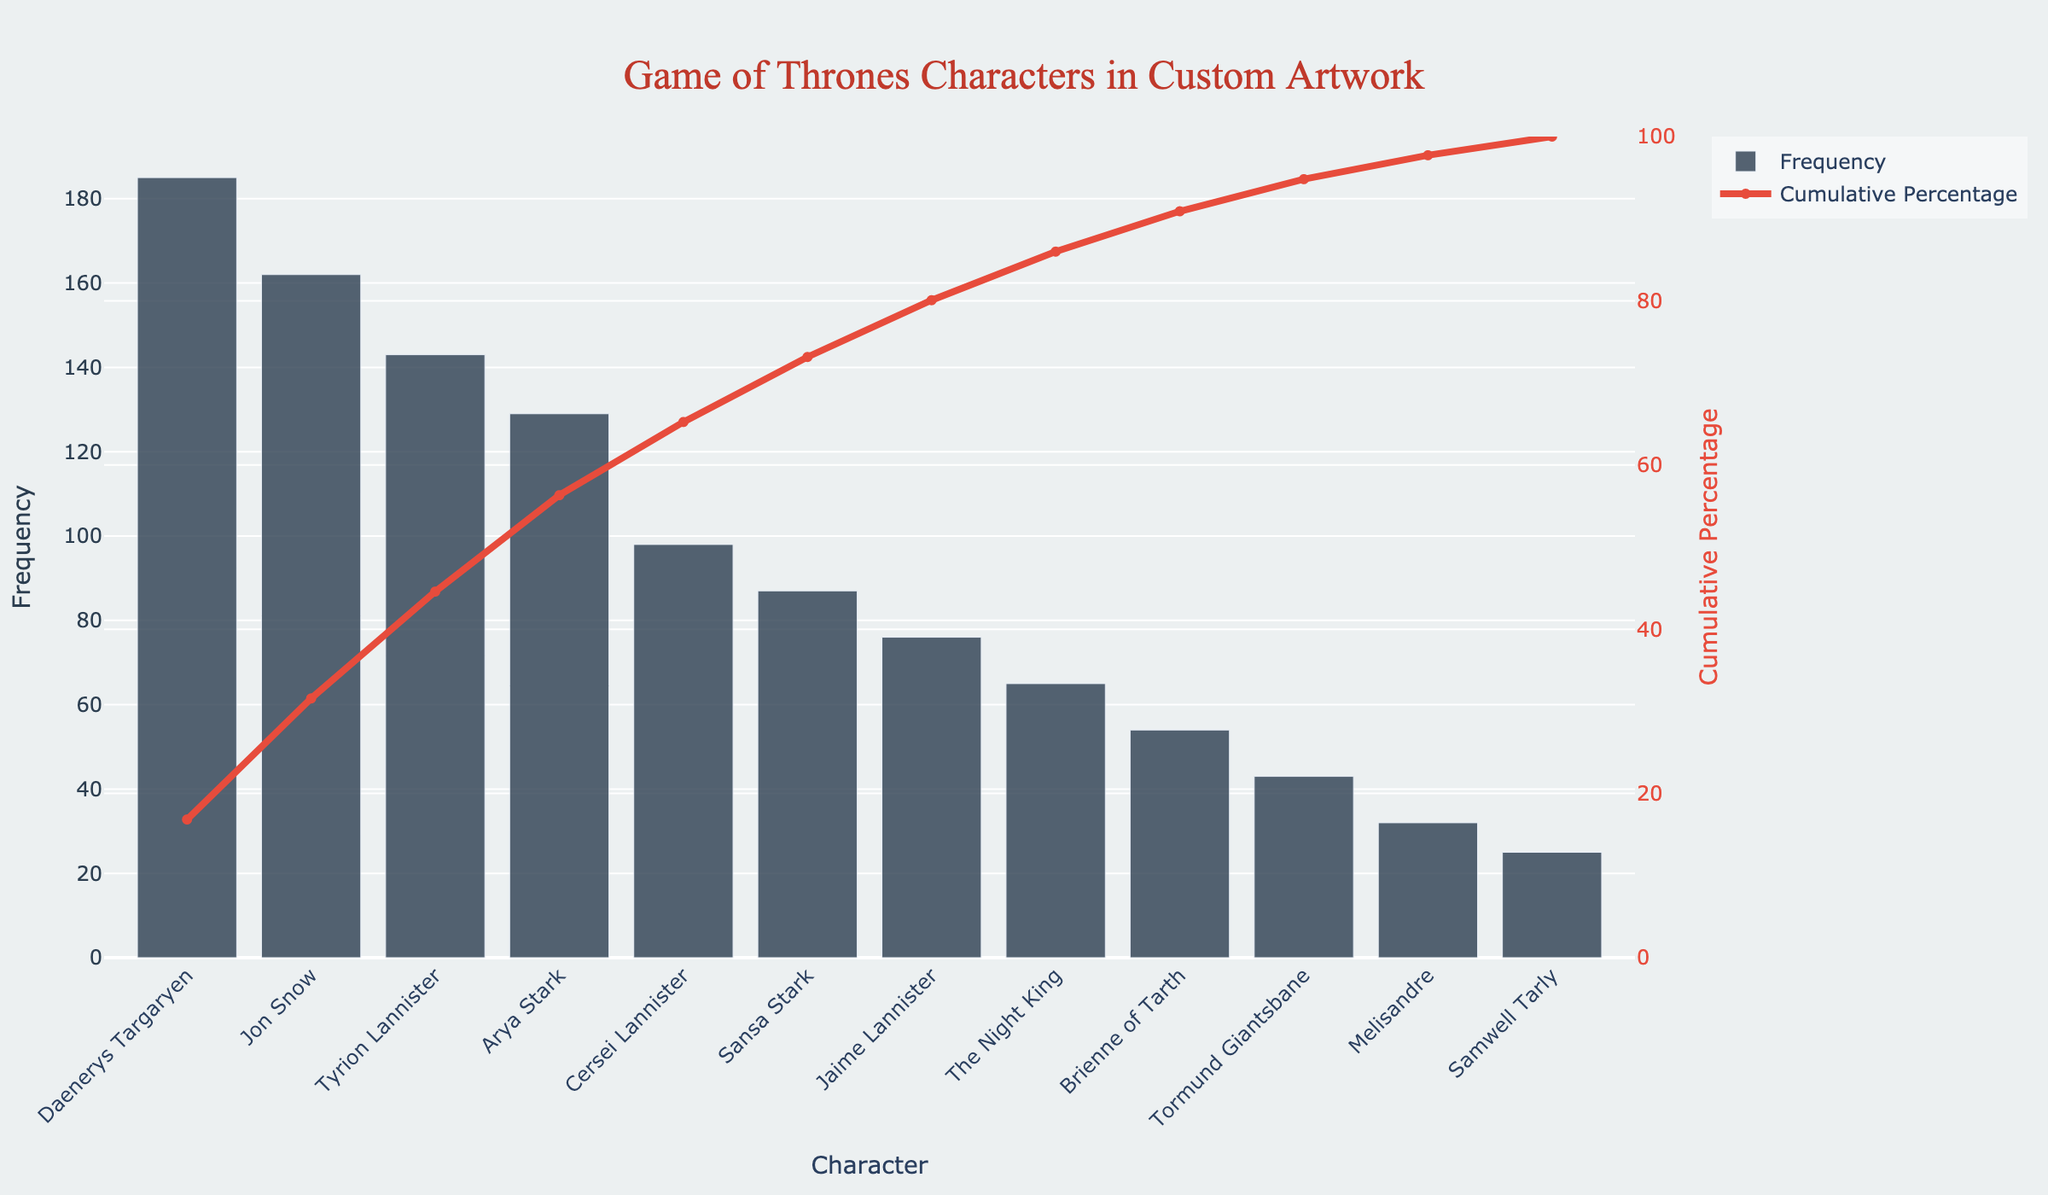What character has the highest frequency in custom artwork? The character with the highest frequency is at the top of the bar chart.
Answer: Daenerys Targaryen What is the cumulative percentage for Daenerys Targaryen and Jon Snow combined? Find the cumulative percentage for Daenerys Targaryen and add it to Jon Snow's frequency percentage. Daenerys has 26.4%, and Jon Snow contributes an additional 18.5%, totaling 44.9%.
Answer: 44.9% How many characters are featured with a frequency of less than 100? Count the number of characters with frequencies below 100 by looking at the y-axis values. There are 7 characters below this threshold.
Answer: 7 Which character has a frequency closest to 100? Look at the bars around the y-axis value of 100, the closest character is Cersei Lannister with a frequency of 98.
Answer: Cersei Lannister What is the cumulative percentage when the frequency reaches Sansa Stark? Trace the red line for cumulative percentage to Sansa Stark. The cumulative percentage for Sansa Stark is around 75.6%.
Answer: 75.6% Between Arya Stark and Jaime Lannister, who has been featured more frequently in custom artwork? Compare the heights of the bars for Arya Stark and Jaime Lannister. Arya Stark has a higher frequency at 129 compared to Jaime Lannister's 76.
Answer: Arya Stark How many characters comprise roughly 80% of the total frequency? Trace the red cumulative percentage line to where it approaches 80% and count the number of characters from the left up to that point. Around 6 characters reach 80%.
Answer: 6 What is the frequency difference between Tyrion Lannister and The Night King? Subtract The Night King's frequency from Tyrion Lannister's frequency: 143 - 65 = 78.
Answer: 78 Which three characters together make up almost 50% of the cumulative frequency? Find the cumulative percentages and see the smallest number of characters that approach 50%. Daenerys Targaryen, Jon Snow, and Tyrion Lannister together make up 50.8%.
Answer: Daenerys Targaryen, Jon Snow, Tyrion Lannister Which character has the lowest frequency, and what is that frequency? Look at the shortest bar on the bar chart, which is Samwell Tarly with a frequency of 25.
Answer: Samwell Tarly How does the cumulative percentage change from Brienne of Tarth to Tormund Giantsbane? Note the cumulative percentages for Brienne of Tarth (87.1%) and Tormund Giantsbane (91.3%), then subtract 87.1% from 91.3%. The change is 4.2%.
Answer: 4.2% 